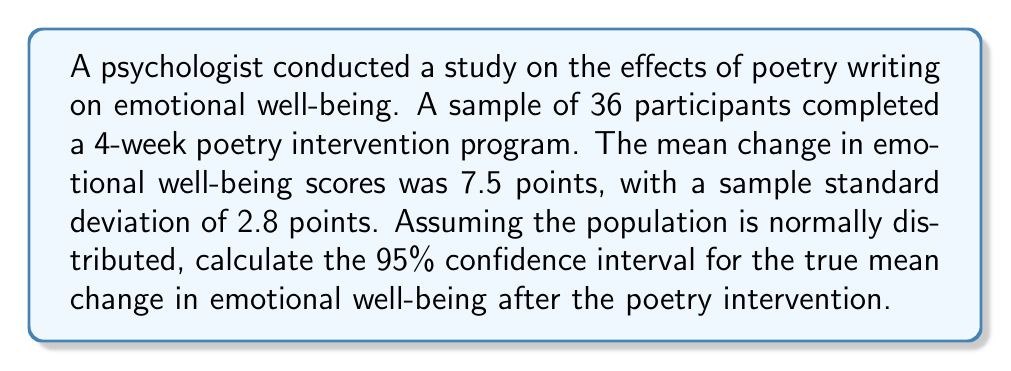Provide a solution to this math problem. To calculate the confidence interval, we'll use the formula:

$$\text{CI} = \bar{x} \pm t_{\alpha/2} \cdot \frac{s}{\sqrt{n}}$$

Where:
$\bar{x}$ = sample mean
$t_{\alpha/2}$ = t-value for 95% confidence level with n-1 degrees of freedom
$s$ = sample standard deviation
$n$ = sample size

Step 1: Identify the known values
$\bar{x} = 7.5$
$s = 2.8$
$n = 36$
Confidence level = 95% (α = 0.05)

Step 2: Find the t-value
Degrees of freedom = n - 1 = 36 - 1 = 35
For a 95% confidence interval with 35 degrees of freedom, $t_{0.025} = 2.030$ (from t-distribution table)

Step 3: Calculate the margin of error
$$\text{Margin of Error} = t_{\alpha/2} \cdot \frac{s}{\sqrt{n}} = 2.030 \cdot \frac{2.8}{\sqrt{36}} = 0.947$$

Step 4: Calculate the confidence interval
Lower bound: $7.5 - 0.947 = 6.553$
Upper bound: $7.5 + 0.947 = 8.447$

Therefore, the 95% confidence interval is (6.553, 8.447).
Answer: (6.553, 8.447) 